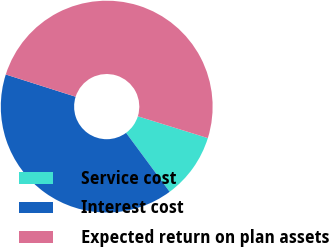Convert chart. <chart><loc_0><loc_0><loc_500><loc_500><pie_chart><fcel>Service cost<fcel>Interest cost<fcel>Expected return on plan assets<nl><fcel>10.07%<fcel>40.03%<fcel>49.9%<nl></chart> 